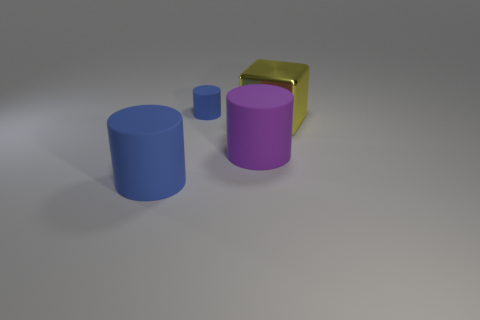Is the material of the cylinder behind the large yellow cube the same as the big yellow object?
Offer a terse response. No. There is a large cylinder that is the same color as the small cylinder; what material is it?
Keep it short and to the point. Rubber. Is there any other thing that is the same shape as the big yellow thing?
Ensure brevity in your answer.  No. What number of objects are either blue matte cylinders or matte objects?
Offer a very short reply. 3. The other blue object that is the same shape as the large blue thing is what size?
Offer a terse response. Small. What number of other objects are the same color as the small cylinder?
Give a very brief answer. 1. What number of cylinders are either tiny cyan things or large yellow metallic things?
Provide a succinct answer. 0. The large thing that is left of the big cylinder that is to the right of the small blue rubber object is what color?
Ensure brevity in your answer.  Blue. What shape is the yellow thing?
Make the answer very short. Cube. There is a blue matte object behind the shiny block; does it have the same size as the big purple object?
Provide a short and direct response. No. 